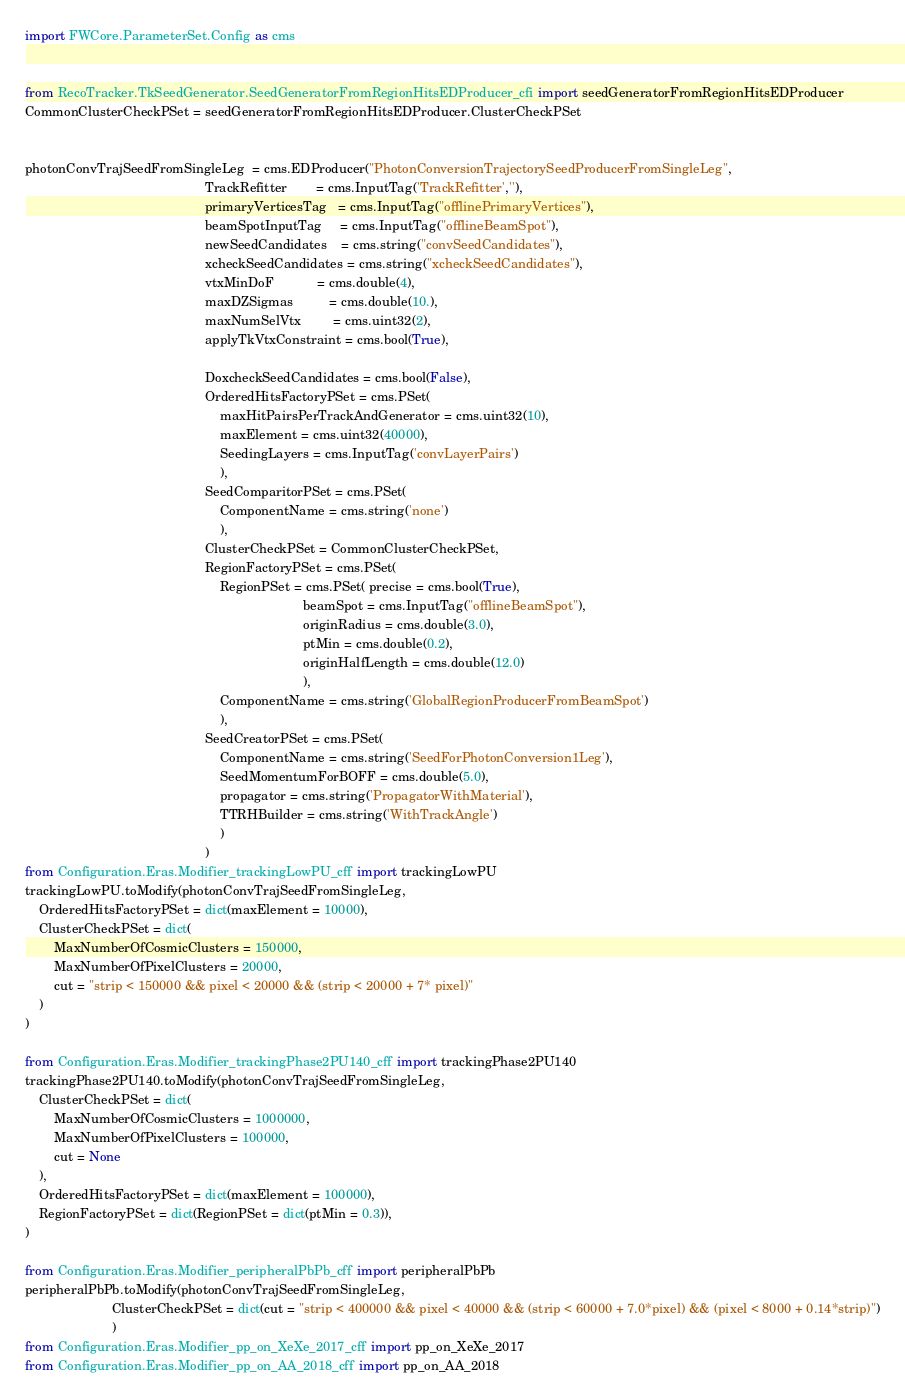<code> <loc_0><loc_0><loc_500><loc_500><_Python_>import FWCore.ParameterSet.Config as cms


from RecoTracker.TkSeedGenerator.SeedGeneratorFromRegionHitsEDProducer_cfi import seedGeneratorFromRegionHitsEDProducer 
CommonClusterCheckPSet = seedGeneratorFromRegionHitsEDProducer.ClusterCheckPSet


photonConvTrajSeedFromSingleLeg  = cms.EDProducer("PhotonConversionTrajectorySeedProducerFromSingleLeg",
                                                  TrackRefitter        = cms.InputTag('TrackRefitter',''),
                                                  primaryVerticesTag   = cms.InputTag("offlinePrimaryVertices"),
                                                  beamSpotInputTag     = cms.InputTag("offlineBeamSpot"),
                                                  newSeedCandidates    = cms.string("convSeedCandidates"),
                                                  xcheckSeedCandidates = cms.string("xcheckSeedCandidates"),
                                                  vtxMinDoF            = cms.double(4),
                                                  maxDZSigmas          = cms.double(10.),
                                                  maxNumSelVtx         = cms.uint32(2),
                                                  applyTkVtxConstraint = cms.bool(True),
                                                  
                                                  DoxcheckSeedCandidates = cms.bool(False),
                                                  OrderedHitsFactoryPSet = cms.PSet(
                                                      maxHitPairsPerTrackAndGenerator = cms.uint32(10),
                                                      maxElement = cms.uint32(40000),
                                                      SeedingLayers = cms.InputTag('convLayerPairs')
                                                      ),
                                                  SeedComparitorPSet = cms.PSet(
                                                      ComponentName = cms.string('none')
                                                      ),
                                                  ClusterCheckPSet = CommonClusterCheckPSet,
                                                  RegionFactoryPSet = cms.PSet(
                                                      RegionPSet = cms.PSet( precise = cms.bool(True),
                                                                             beamSpot = cms.InputTag("offlineBeamSpot"),
                                                                             originRadius = cms.double(3.0),
                                                                             ptMin = cms.double(0.2),
                                                                             originHalfLength = cms.double(12.0)
                                                                             ),
                                                      ComponentName = cms.string('GlobalRegionProducerFromBeamSpot')
                                                      ),
                                                  SeedCreatorPSet = cms.PSet(
                                                      ComponentName = cms.string('SeedForPhotonConversion1Leg'),
                                                      SeedMomentumForBOFF = cms.double(5.0),
                                                      propagator = cms.string('PropagatorWithMaterial'),
                                                      TTRHBuilder = cms.string('WithTrackAngle')
                                                      )
                                                  )
from Configuration.Eras.Modifier_trackingLowPU_cff import trackingLowPU
trackingLowPU.toModify(photonConvTrajSeedFromSingleLeg,
    OrderedHitsFactoryPSet = dict(maxElement = 10000),
    ClusterCheckPSet = dict(
        MaxNumberOfCosmicClusters = 150000,
        MaxNumberOfPixelClusters = 20000,
        cut = "strip < 150000 && pixel < 20000 && (strip < 20000 + 7* pixel)"
    )
)

from Configuration.Eras.Modifier_trackingPhase2PU140_cff import trackingPhase2PU140
trackingPhase2PU140.toModify(photonConvTrajSeedFromSingleLeg,
    ClusterCheckPSet = dict(
        MaxNumberOfCosmicClusters = 1000000,
        MaxNumberOfPixelClusters = 100000,
        cut = None
    ),
    OrderedHitsFactoryPSet = dict(maxElement = 100000),
    RegionFactoryPSet = dict(RegionPSet = dict(ptMin = 0.3)),
)

from Configuration.Eras.Modifier_peripheralPbPb_cff import peripheralPbPb
peripheralPbPb.toModify(photonConvTrajSeedFromSingleLeg,
                        ClusterCheckPSet = dict(cut = "strip < 400000 && pixel < 40000 && (strip < 60000 + 7.0*pixel) && (pixel < 8000 + 0.14*strip)")
                        )
from Configuration.Eras.Modifier_pp_on_XeXe_2017_cff import pp_on_XeXe_2017
from Configuration.Eras.Modifier_pp_on_AA_2018_cff import pp_on_AA_2018</code> 